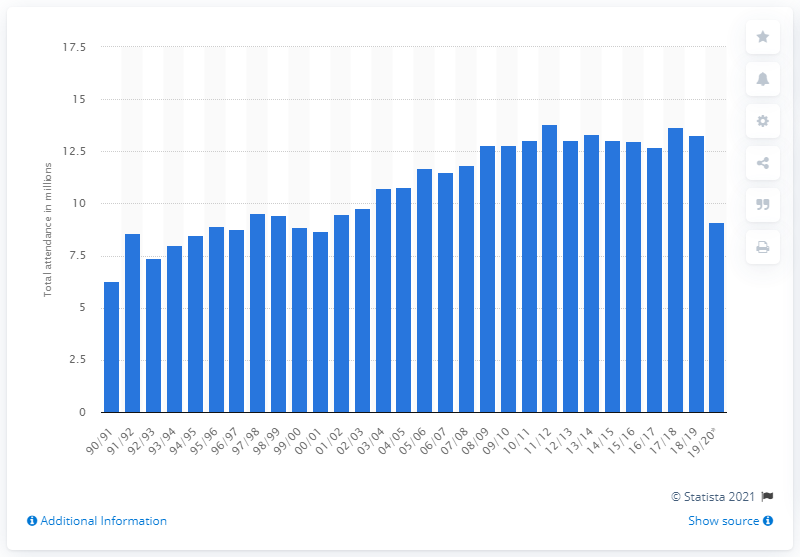Highlight a few significant elements in this photo. In the 2019/2020 season of the German football Bundesliga, a total of 9.11 fans attended the games. 